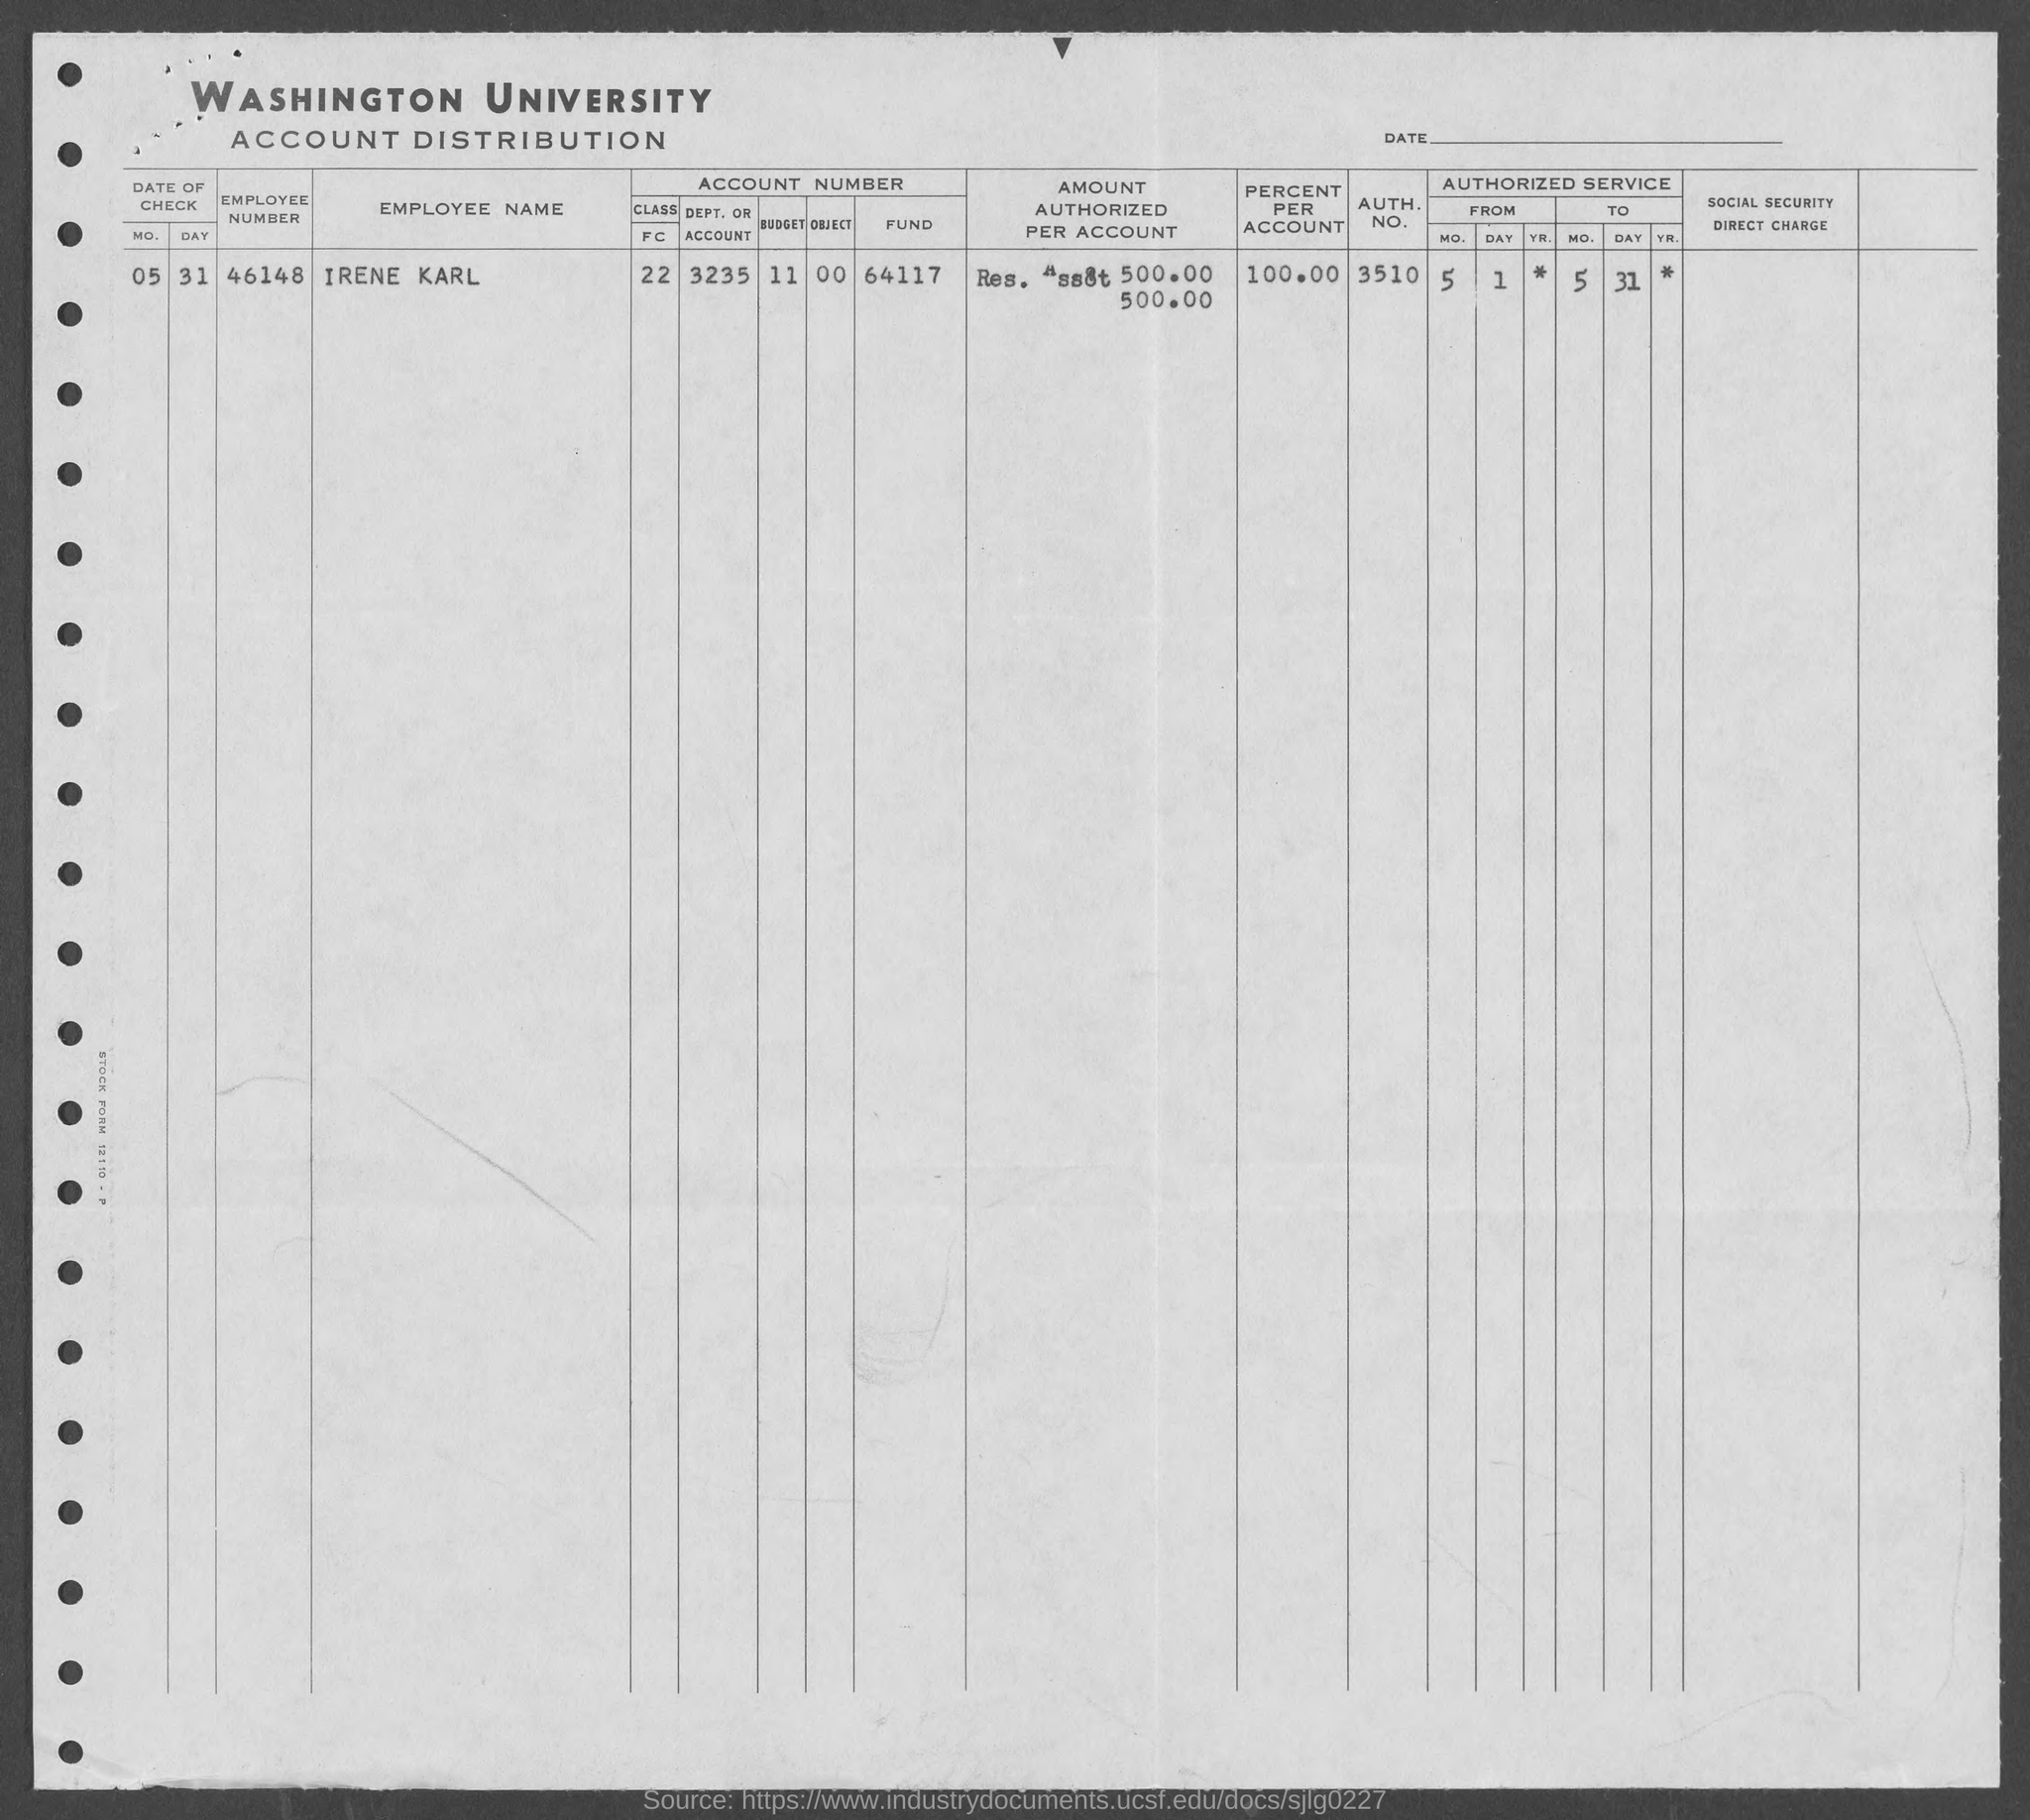What is the employee number of irene karl ?
Your response must be concise. 46148. What is percent per account of irene karl ?
Offer a terse response. 100. What is the auth. no. of irene karl ?
Make the answer very short. 3510. 